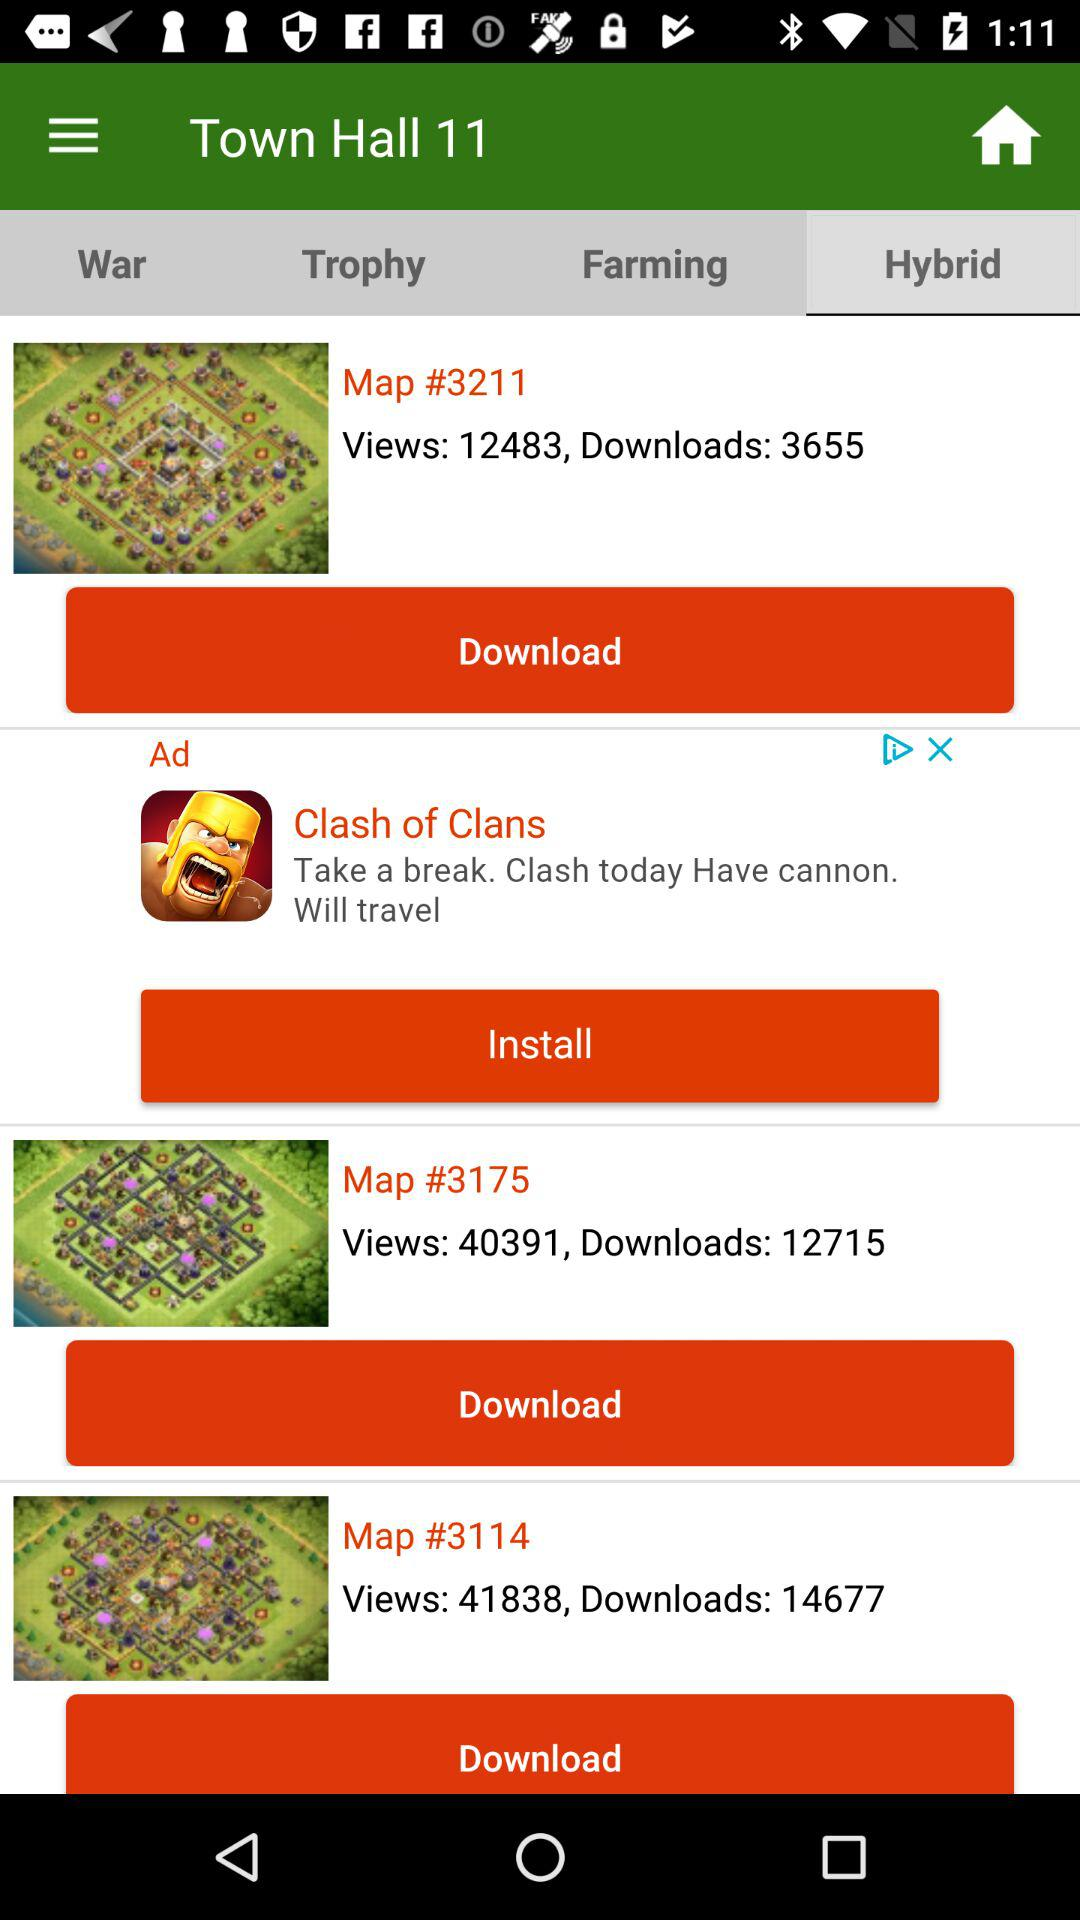How many views are on Map #3211? There are 12483 views on Map #3211. 